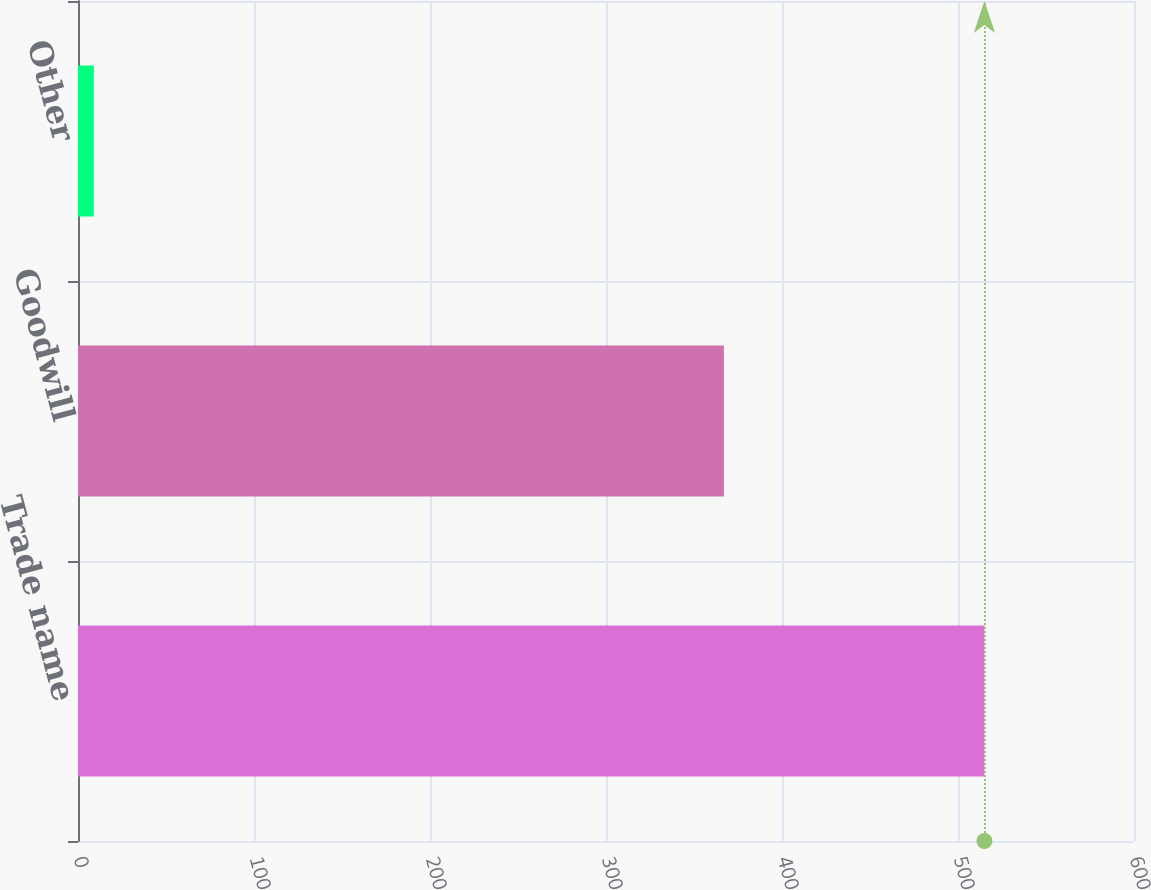<chart> <loc_0><loc_0><loc_500><loc_500><bar_chart><fcel>Trade name<fcel>Goodwill<fcel>Other<nl><fcel>515<fcel>367<fcel>9<nl></chart> 